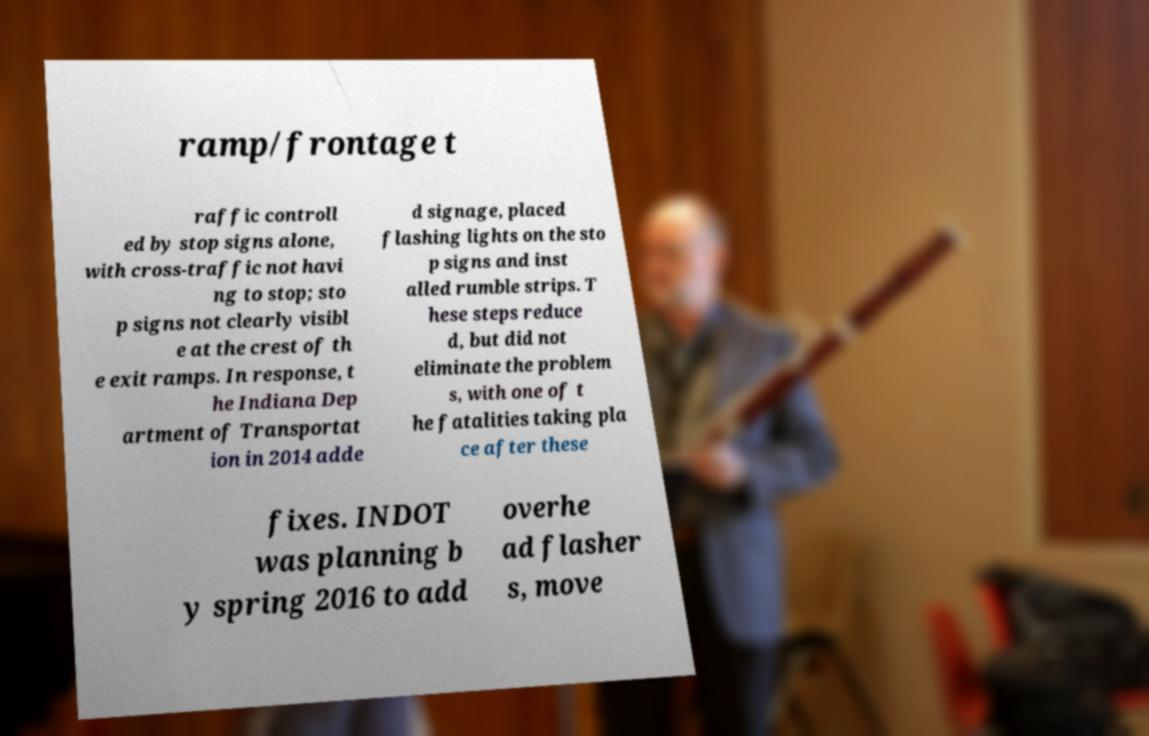Can you read and provide the text displayed in the image?This photo seems to have some interesting text. Can you extract and type it out for me? ramp/frontage t raffic controll ed by stop signs alone, with cross-traffic not havi ng to stop; sto p signs not clearly visibl e at the crest of th e exit ramps. In response, t he Indiana Dep artment of Transportat ion in 2014 adde d signage, placed flashing lights on the sto p signs and inst alled rumble strips. T hese steps reduce d, but did not eliminate the problem s, with one of t he fatalities taking pla ce after these fixes. INDOT was planning b y spring 2016 to add overhe ad flasher s, move 